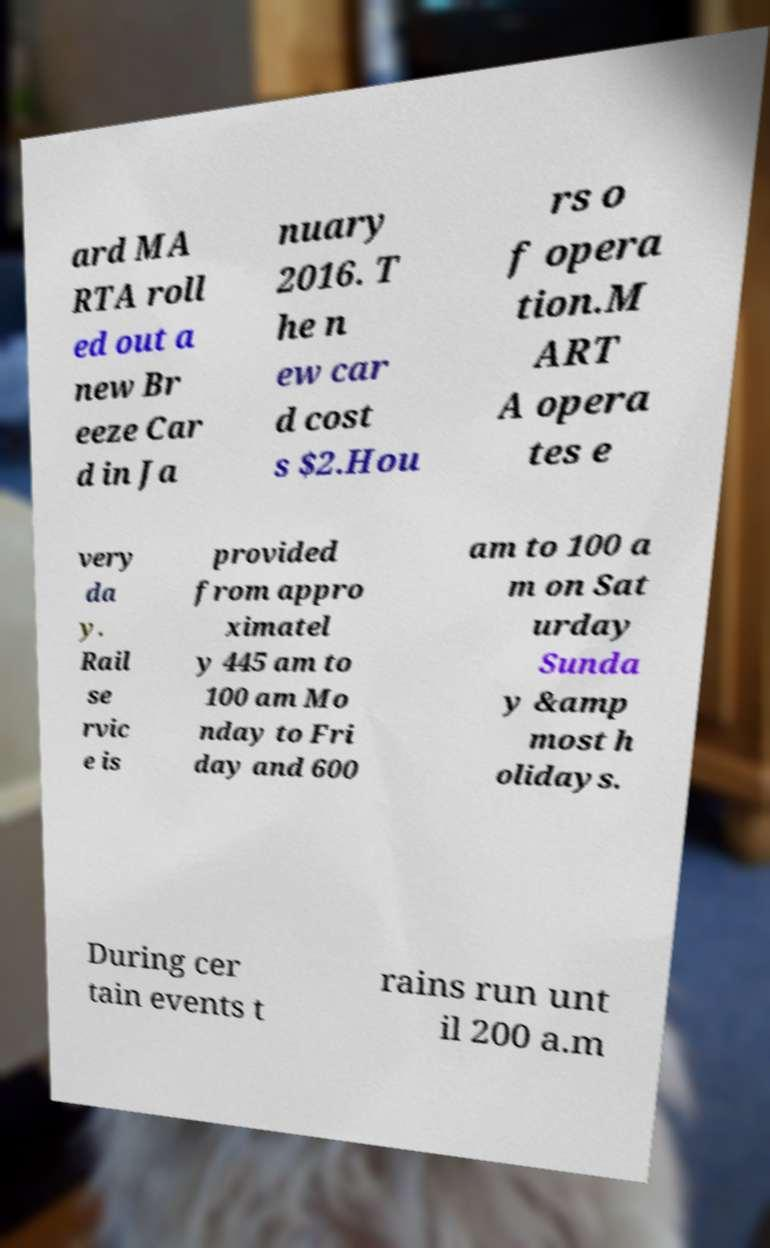What messages or text are displayed in this image? I need them in a readable, typed format. ard MA RTA roll ed out a new Br eeze Car d in Ja nuary 2016. T he n ew car d cost s $2.Hou rs o f opera tion.M ART A opera tes e very da y. Rail se rvic e is provided from appro ximatel y 445 am to 100 am Mo nday to Fri day and 600 am to 100 a m on Sat urday Sunda y &amp most h olidays. During cer tain events t rains run unt il 200 a.m 